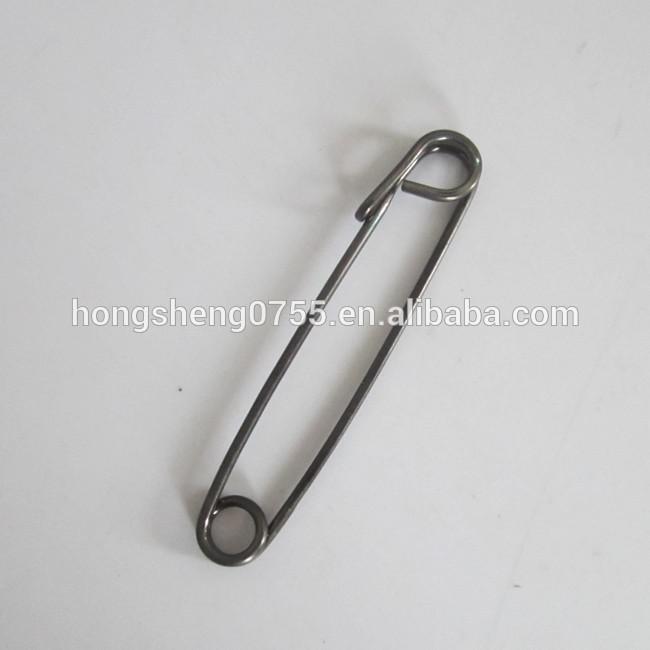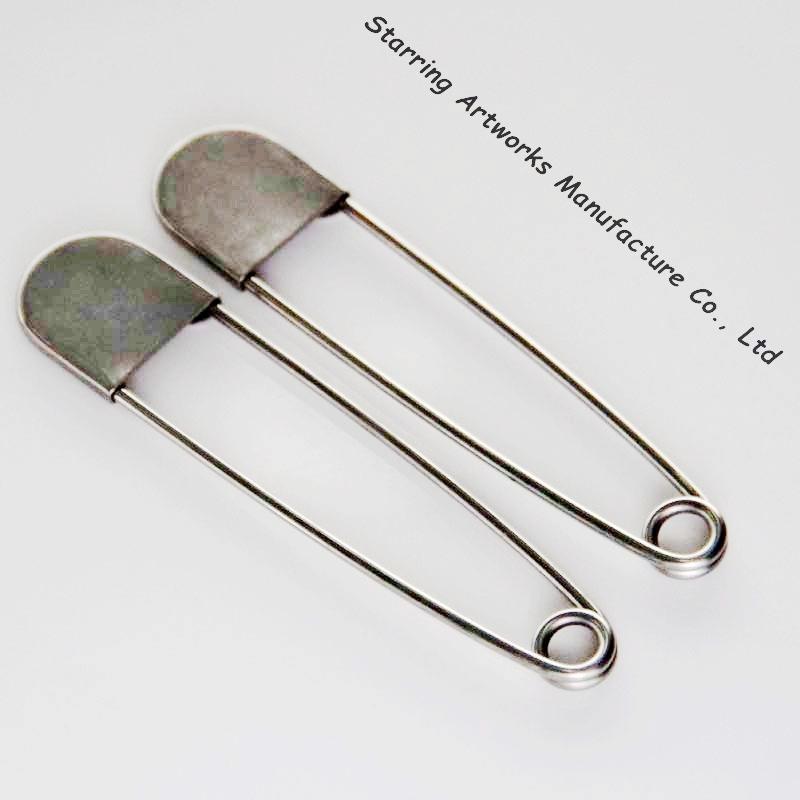The first image is the image on the left, the second image is the image on the right. Examine the images to the left and right. Is the description "In at least one image the clip is not silver at all." accurate? Answer yes or no. No. 